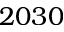<formula> <loc_0><loc_0><loc_500><loc_500>2 0 3 0</formula> 